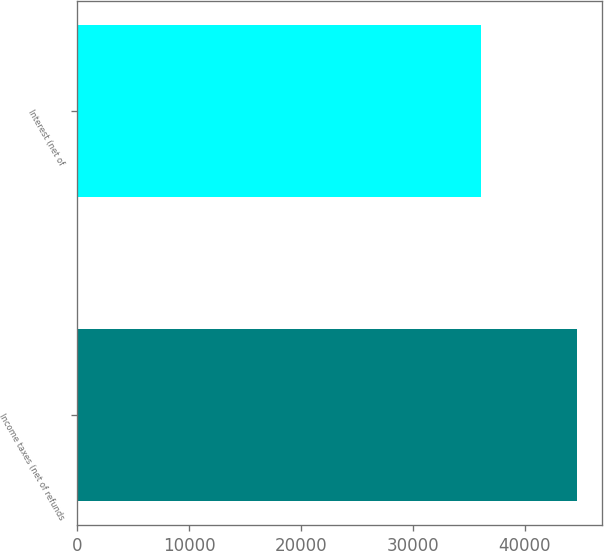Convert chart. <chart><loc_0><loc_0><loc_500><loc_500><bar_chart><fcel>Income taxes (net of refunds<fcel>Interest (net of<nl><fcel>44621<fcel>36084<nl></chart> 